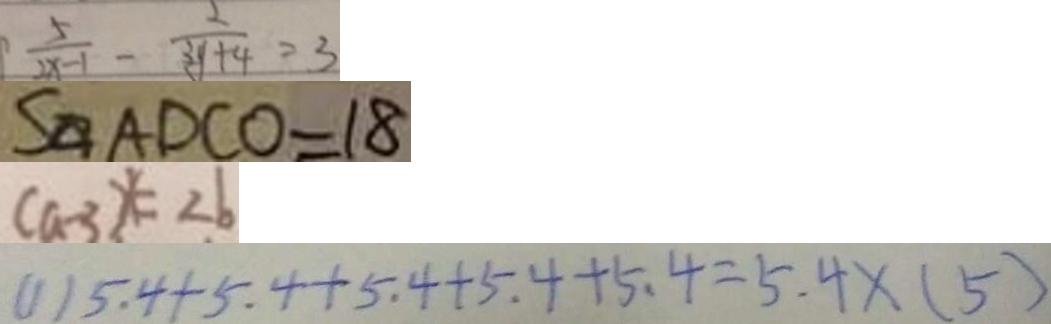<formula> <loc_0><loc_0><loc_500><loc_500>\frac { 5 } { 2 x - 1 } - \frac { 2 } { 3 y + 4 } = 3 
 S _ { \square A D C O } = 1 8 
 ( a - 3 ) = 2 b 
 ( 1 ) 5 . 4 + 5 . 4 + 5 . 4 + 5 . 4 + 5 . 4 = 5 . 4 \times ( 5 )</formula> 